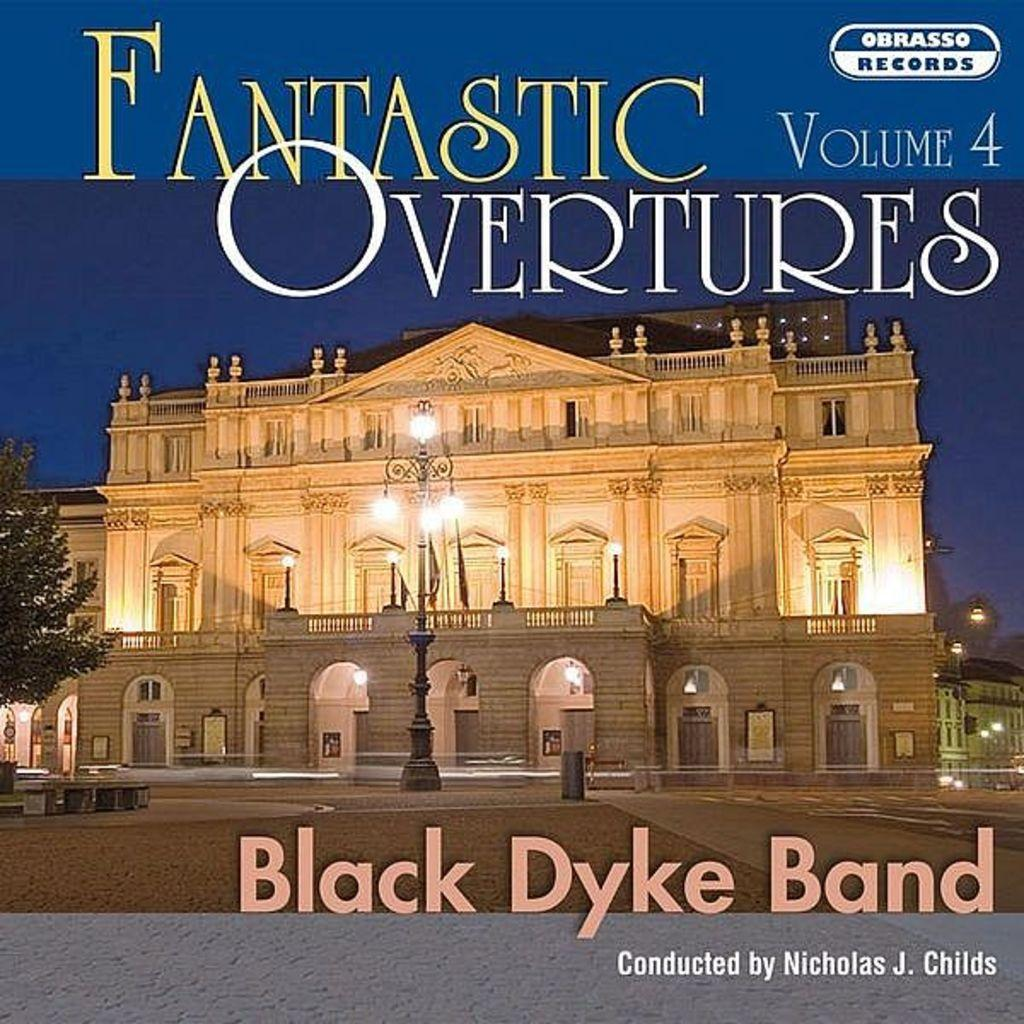What is featured on the poster in the image? The poster contains a picture of a building. Is there any text on the poster? Yes, there is text on the poster. What type of steam is coming out of the building in the poster? There is no steam present in the image, as it only features a poster with a picture of a building and text. 